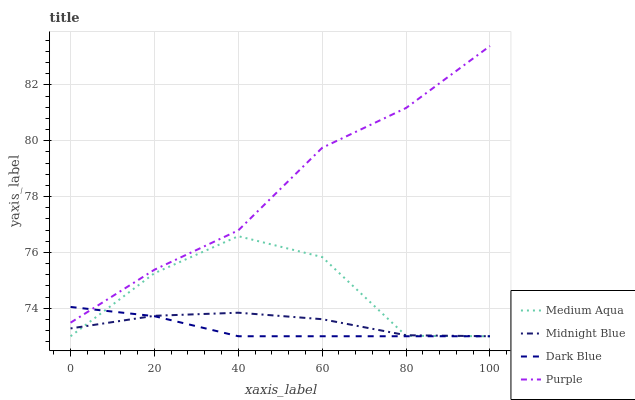Does Dark Blue have the minimum area under the curve?
Answer yes or no. Yes. Does Purple have the maximum area under the curve?
Answer yes or no. Yes. Does Medium Aqua have the minimum area under the curve?
Answer yes or no. No. Does Medium Aqua have the maximum area under the curve?
Answer yes or no. No. Is Dark Blue the smoothest?
Answer yes or no. Yes. Is Medium Aqua the roughest?
Answer yes or no. Yes. Is Medium Aqua the smoothest?
Answer yes or no. No. Is Dark Blue the roughest?
Answer yes or no. No. Does Purple have the highest value?
Answer yes or no. Yes. Does Dark Blue have the highest value?
Answer yes or no. No. Is Midnight Blue less than Purple?
Answer yes or no. Yes. Is Purple greater than Medium Aqua?
Answer yes or no. Yes. Does Dark Blue intersect Purple?
Answer yes or no. Yes. Is Dark Blue less than Purple?
Answer yes or no. No. Is Dark Blue greater than Purple?
Answer yes or no. No. Does Midnight Blue intersect Purple?
Answer yes or no. No. 